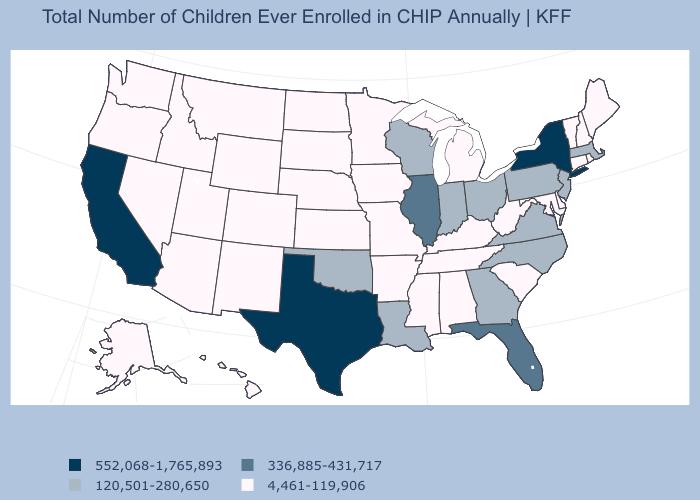What is the lowest value in the West?
Be succinct. 4,461-119,906. What is the value of Hawaii?
Answer briefly. 4,461-119,906. What is the lowest value in states that border New Jersey?
Quick response, please. 4,461-119,906. Does the map have missing data?
Short answer required. No. What is the value of Idaho?
Be succinct. 4,461-119,906. Does the first symbol in the legend represent the smallest category?
Write a very short answer. No. Which states hav the highest value in the Northeast?
Short answer required. New York. Name the states that have a value in the range 336,885-431,717?
Write a very short answer. Florida, Illinois. Does Iowa have a higher value than Washington?
Give a very brief answer. No. Does Florida have the highest value in the South?
Answer briefly. No. Which states hav the highest value in the Northeast?
Concise answer only. New York. Among the states that border Delaware , does Maryland have the lowest value?
Quick response, please. Yes. Does Kentucky have a higher value than Hawaii?
Keep it brief. No. Name the states that have a value in the range 336,885-431,717?
Answer briefly. Florida, Illinois. Does California have the highest value in the West?
Short answer required. Yes. 